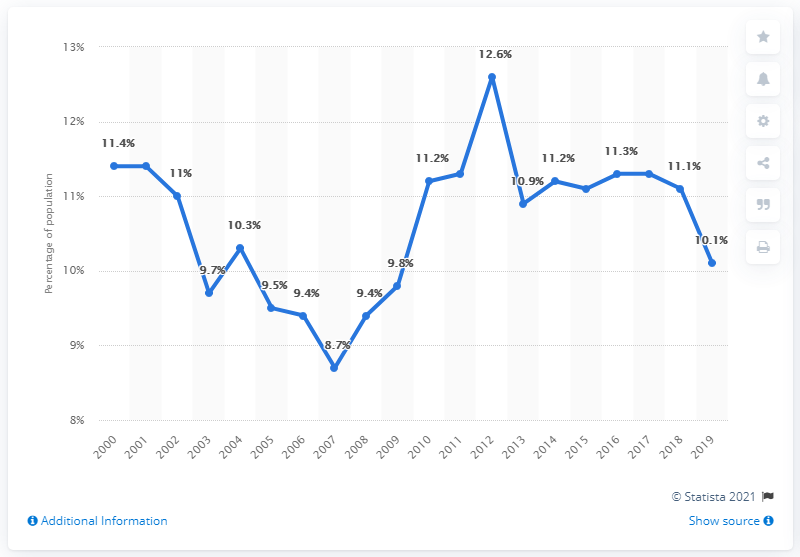Give some essential details in this illustration. In 2019, approximately 10.1% of Wyoming's population lived below the poverty line. 